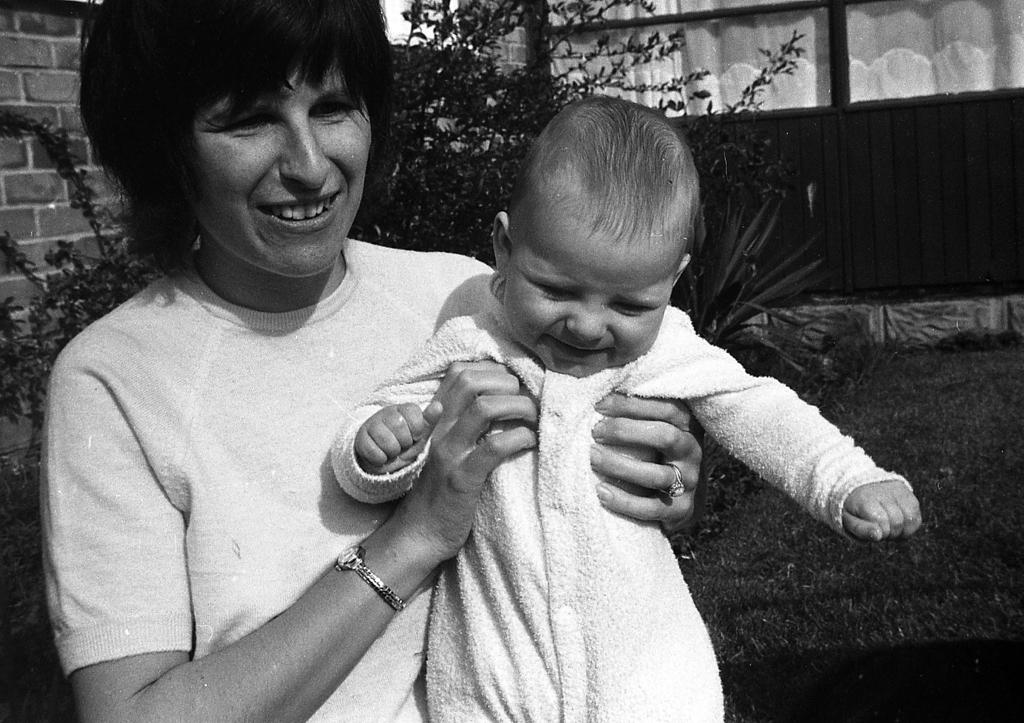Who is the main subject in the image? There is a woman in the image. What is the woman doing in the image? The woman is holding a baby. How are the woman and the baby feeling in the image? Both the woman and the baby are smiling. What can be seen in the background of the image? There are plants in the background of the image. What is the color scheme of the image? The image is black and white. What type of pet can be seen in the wilderness in the image? There is no pet or wilderness present in the image. How much debt is the woman in the image currently facing? There is no information about the woman's debt in the image. 